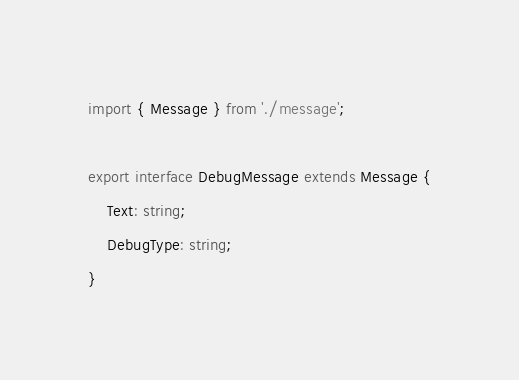Convert code to text. <code><loc_0><loc_0><loc_500><loc_500><_TypeScript_>import { Message } from './message';

export interface DebugMessage extends Message {
    Text: string;
    DebugType: string;
}
</code> 